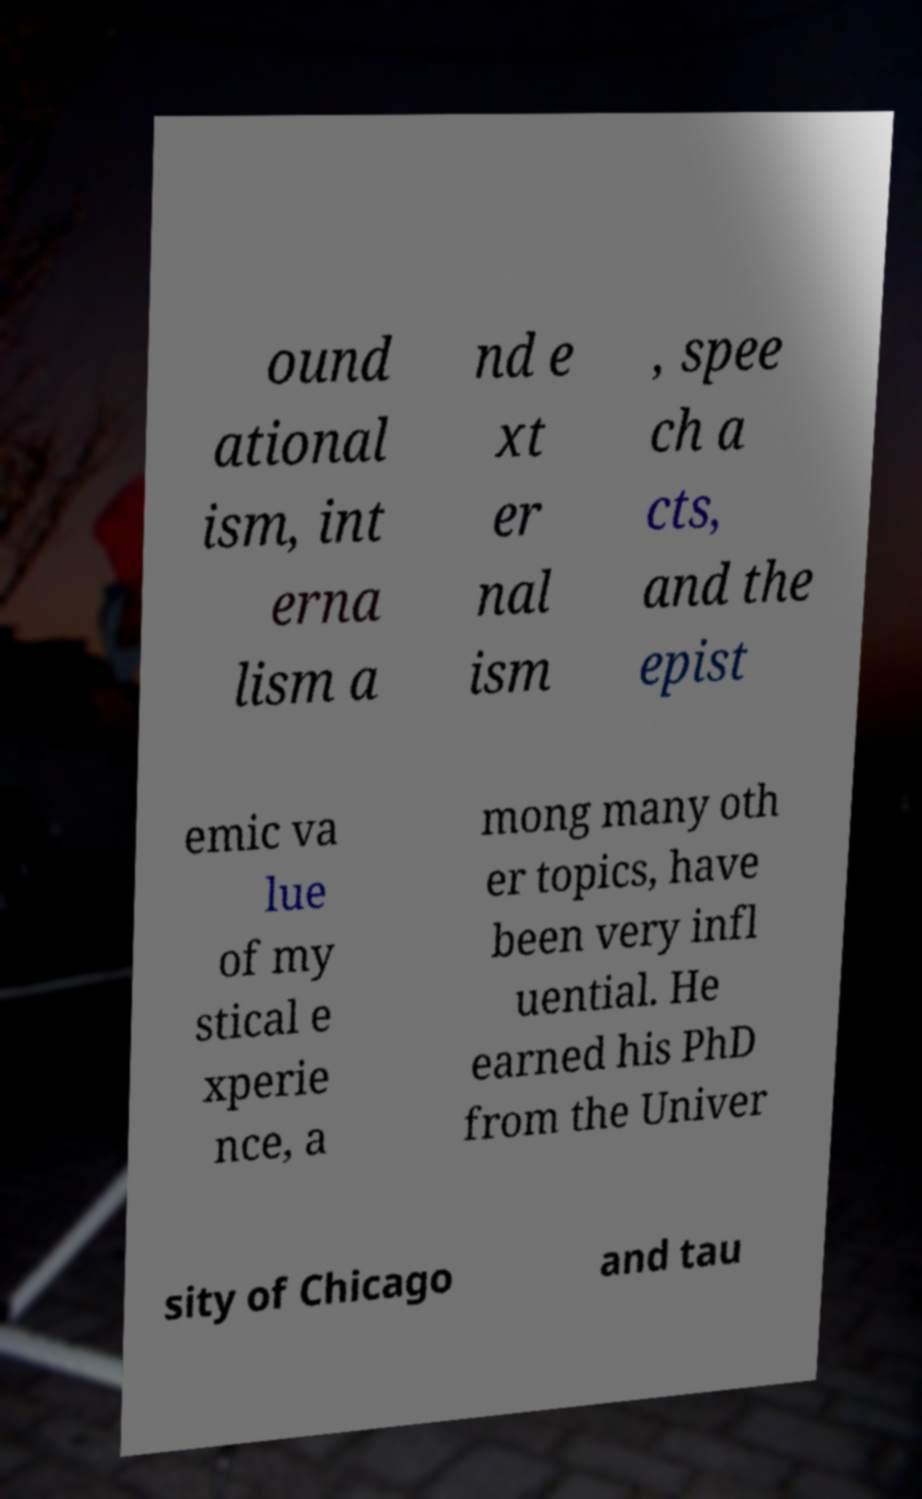Could you assist in decoding the text presented in this image and type it out clearly? ound ational ism, int erna lism a nd e xt er nal ism , spee ch a cts, and the epist emic va lue of my stical e xperie nce, a mong many oth er topics, have been very infl uential. He earned his PhD from the Univer sity of Chicago and tau 